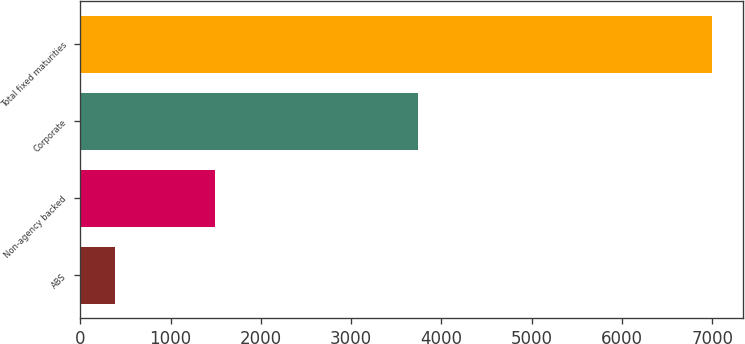Convert chart. <chart><loc_0><loc_0><loc_500><loc_500><bar_chart><fcel>ABS<fcel>Non-agency backed<fcel>Corporate<fcel>Total fixed maturities<nl><fcel>380<fcel>1489<fcel>3740<fcel>6994<nl></chart> 